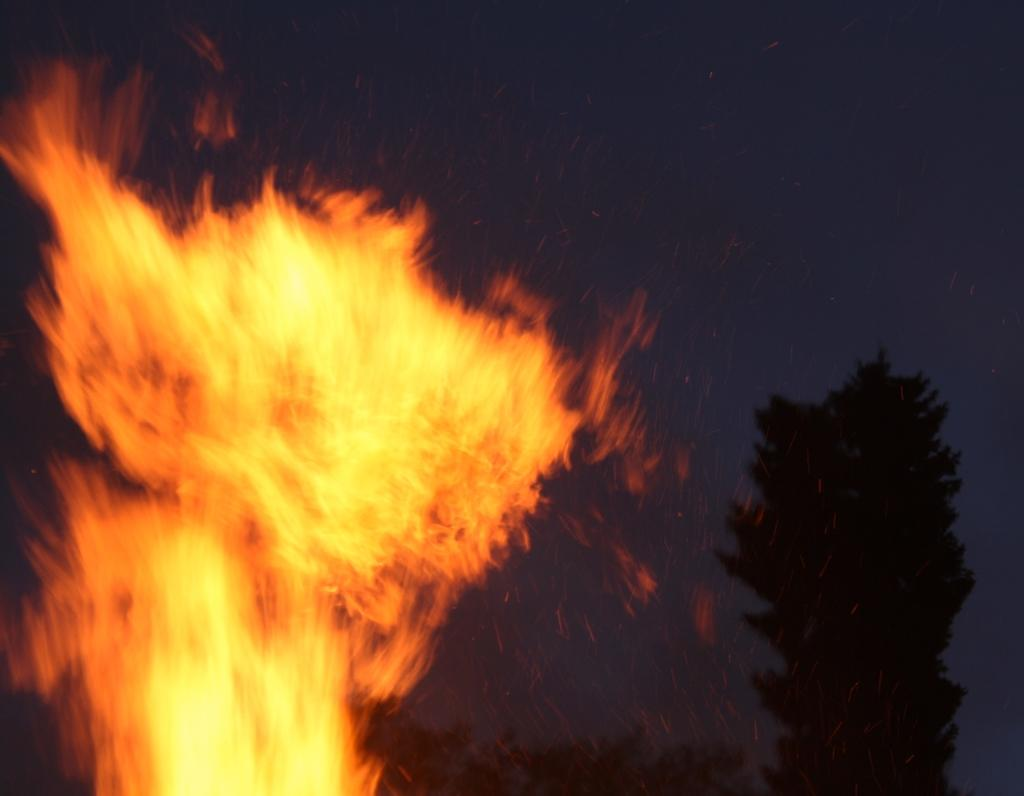What is the primary element in the image? There is fire in the image. What can be seen in the background of the image? There are trees in the background of the image. What type of design can be seen on the hill in the image? There is no hill present in the image, and therefore no design can be observed on it. 